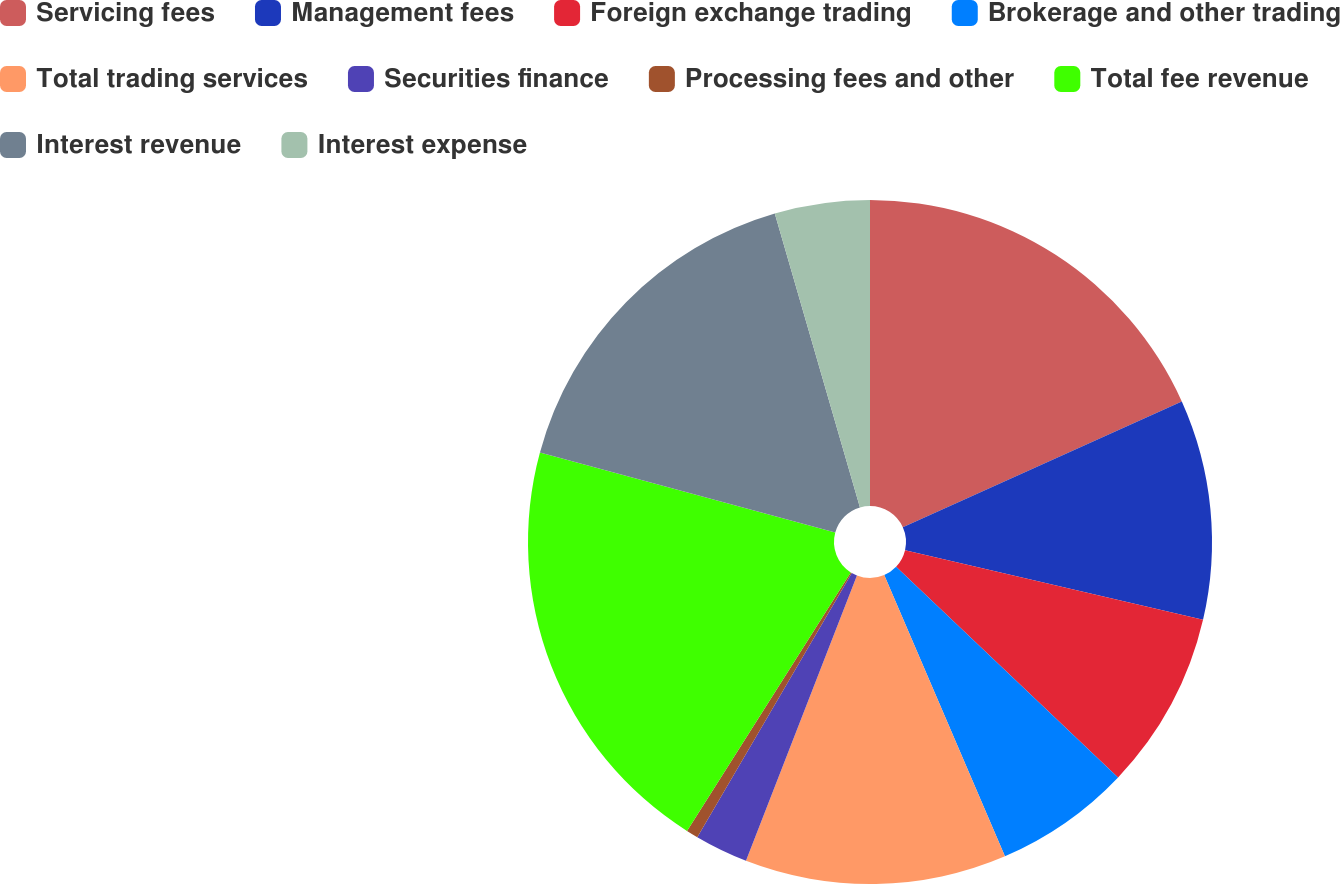Convert chart to OTSL. <chart><loc_0><loc_0><loc_500><loc_500><pie_chart><fcel>Servicing fees<fcel>Management fees<fcel>Foreign exchange trading<fcel>Brokerage and other trading<fcel>Total trading services<fcel>Securities finance<fcel>Processing fees and other<fcel>Total fee revenue<fcel>Interest revenue<fcel>Interest expense<nl><fcel>18.26%<fcel>10.39%<fcel>8.43%<fcel>6.46%<fcel>12.36%<fcel>2.52%<fcel>0.56%<fcel>20.23%<fcel>16.29%<fcel>4.49%<nl></chart> 